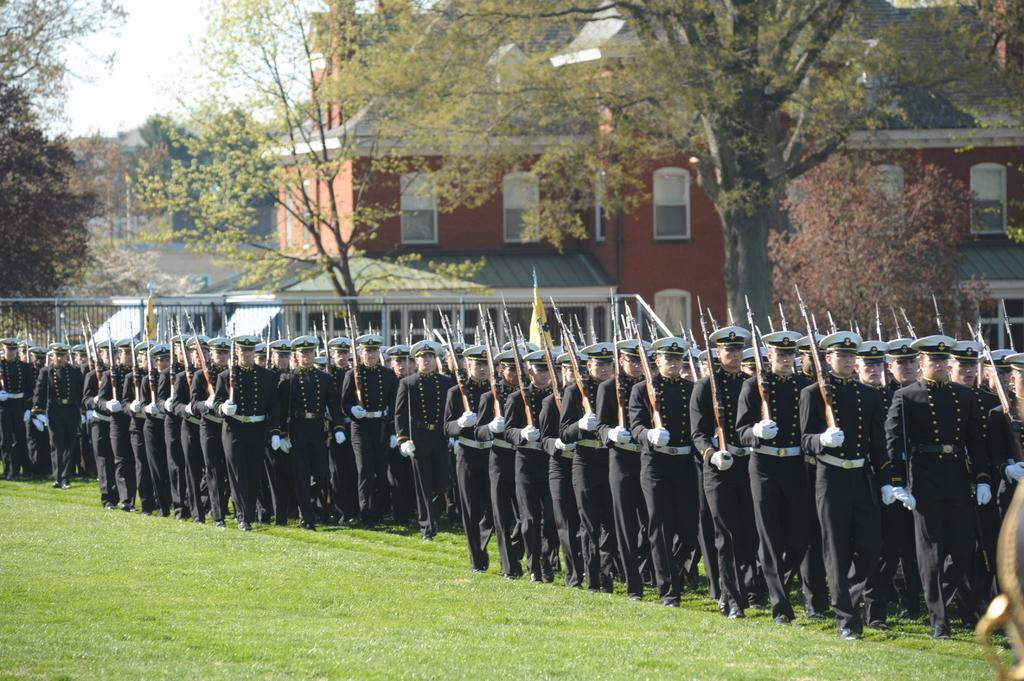Please provide a concise description of this image. In this picture we can see group of people, they wore caps and few people holding guns, and they are walking on the grass, in the background we can see few buildings and trees. 